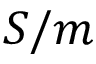<formula> <loc_0><loc_0><loc_500><loc_500>S / m</formula> 